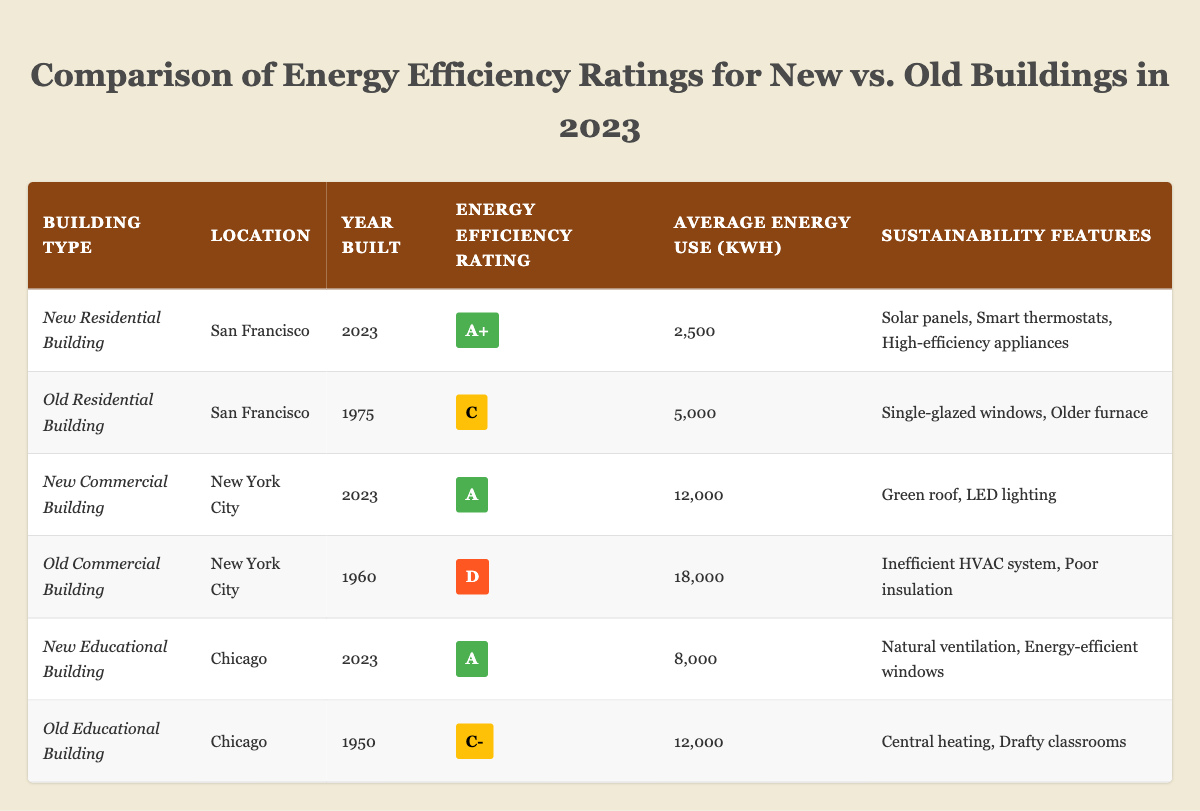What is the energy efficiency rating of the New Residential Building in San Francisco? The table shows the New Residential Building's rating in the relevant row, which is marked as "A+".
Answer: A+ How much average energy does the Old Commercial Building in New York City use? Looking at the table, the Old Commercial Building's average energy use is listed as 18,000 kWh.
Answer: 18,000 kWh What sustainability features are present in the New Educational Building? By examining the row for the New Educational Building in the table, the sustainability features are listed as "Natural ventilation" and "Energy-efficient windows."
Answer: Natural ventilation, Energy-efficient windows How many old buildings have an energy efficiency rating of C or lower? The table reveals two buildings with ratings of C or lower: the Old Residential Building (C) and the Old Commercial Building (D). Thus, there are two such buildings.
Answer: 2 What is the average energy use of the new buildings listed in the table? To find the average energy use of new buildings, sum their average energy uses: 2,500 + 12,000 + 8,000 = 22,500. There are three new buildings, so the average is 22,500 / 3 = 7,500 kWh.
Answer: 7,500 kWh Is the energy efficiency rating of the New Residential Building higher than that of the Old Educational Building? The New Residential Building has an "A+" rating, while the Old Educational Building has a "C-". It is clear that "A+" is indeed higher than "C-".
Answer: Yes What is the total average energy use of all buildings listed in the table? The total average energy use is calculated by summing all average use figures: 2,500 + 5,000 + 12,000 + 18,000 + 8,000 + 12,000 = 57,500 kWh. There are six buildings, so the total average energy use is 57,500 kWh.
Answer: 57,500 kWh Which type of building has the highest energy efficiency rating? Checking the ratings, the New Residential Building has "A+" while others range lower. Therefore, it has the highest rating.
Answer: New Residential Building Are there any old buildings that have solar panels as a feature? The table indicates that the Old Residential Building does not have solar panels and lists features that do not include them. Hence, there are no old buildings with this feature.
Answer: No What percentage of the listed buildings have an energy efficiency rating of A or higher? There are four total buildings with ratings A or higher: New Residential Building (A+), New Commercial Building (A), New Educational Building (A). With 6 buildings total, the percentage is (3/6) * 100 = 50%.
Answer: 50% 